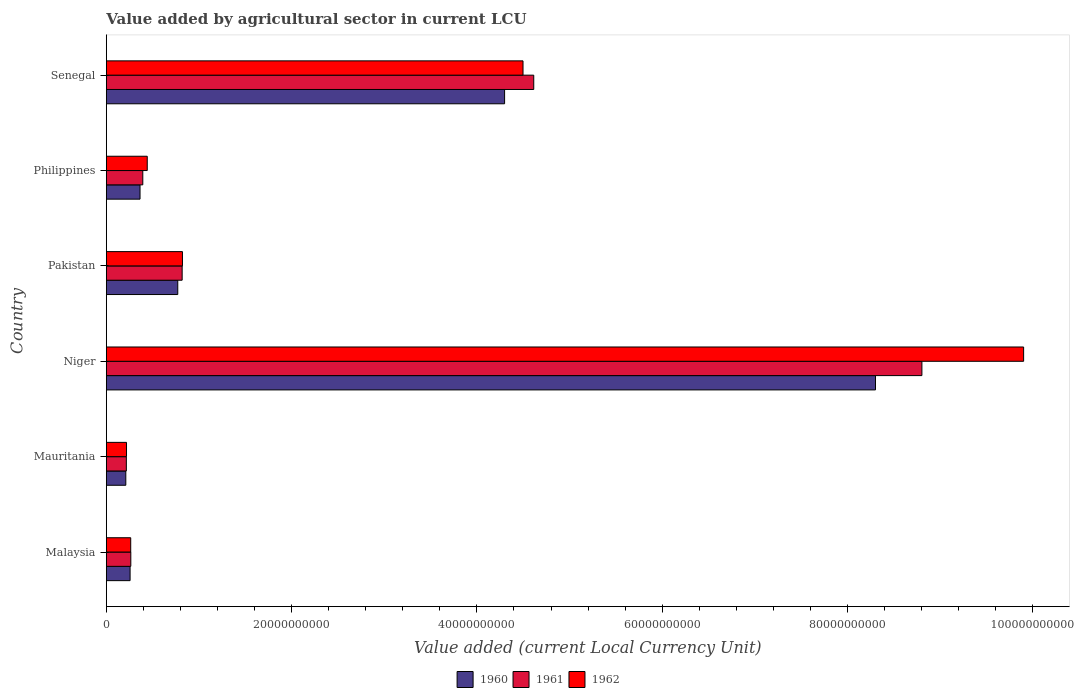How many different coloured bars are there?
Keep it short and to the point. 3. How many groups of bars are there?
Your response must be concise. 6. Are the number of bars per tick equal to the number of legend labels?
Provide a succinct answer. Yes. Are the number of bars on each tick of the Y-axis equal?
Your response must be concise. Yes. What is the label of the 6th group of bars from the top?
Give a very brief answer. Malaysia. What is the value added by agricultural sector in 1961 in Niger?
Offer a very short reply. 8.80e+1. Across all countries, what is the maximum value added by agricultural sector in 1960?
Your answer should be compact. 8.30e+1. Across all countries, what is the minimum value added by agricultural sector in 1960?
Keep it short and to the point. 2.10e+09. In which country was the value added by agricultural sector in 1961 maximum?
Your response must be concise. Niger. In which country was the value added by agricultural sector in 1962 minimum?
Offer a terse response. Mauritania. What is the total value added by agricultural sector in 1961 in the graph?
Make the answer very short. 1.51e+11. What is the difference between the value added by agricultural sector in 1962 in Malaysia and that in Pakistan?
Keep it short and to the point. -5.58e+09. What is the difference between the value added by agricultural sector in 1960 in Philippines and the value added by agricultural sector in 1961 in Niger?
Provide a short and direct response. -8.44e+1. What is the average value added by agricultural sector in 1962 per country?
Offer a very short reply. 2.69e+1. What is the difference between the value added by agricultural sector in 1960 and value added by agricultural sector in 1962 in Pakistan?
Offer a terse response. -5.05e+08. What is the ratio of the value added by agricultural sector in 1960 in Mauritania to that in Pakistan?
Keep it short and to the point. 0.27. Is the value added by agricultural sector in 1962 in Malaysia less than that in Pakistan?
Your response must be concise. Yes. What is the difference between the highest and the second highest value added by agricultural sector in 1960?
Offer a terse response. 4.00e+1. What is the difference between the highest and the lowest value added by agricultural sector in 1962?
Your response must be concise. 9.68e+1. Is the sum of the value added by agricultural sector in 1962 in Pakistan and Philippines greater than the maximum value added by agricultural sector in 1960 across all countries?
Ensure brevity in your answer.  No. What does the 3rd bar from the top in Mauritania represents?
Keep it short and to the point. 1960. What does the 1st bar from the bottom in Malaysia represents?
Offer a terse response. 1960. Is it the case that in every country, the sum of the value added by agricultural sector in 1961 and value added by agricultural sector in 1960 is greater than the value added by agricultural sector in 1962?
Your answer should be very brief. Yes. Are all the bars in the graph horizontal?
Offer a very short reply. Yes. What is the difference between two consecutive major ticks on the X-axis?
Your answer should be very brief. 2.00e+1. Does the graph contain any zero values?
Give a very brief answer. No. Where does the legend appear in the graph?
Keep it short and to the point. Bottom center. What is the title of the graph?
Make the answer very short. Value added by agricultural sector in current LCU. What is the label or title of the X-axis?
Provide a succinct answer. Value added (current Local Currency Unit). What is the Value added (current Local Currency Unit) of 1960 in Malaysia?
Keep it short and to the point. 2.56e+09. What is the Value added (current Local Currency Unit) of 1961 in Malaysia?
Make the answer very short. 2.64e+09. What is the Value added (current Local Currency Unit) in 1962 in Malaysia?
Your answer should be compact. 2.63e+09. What is the Value added (current Local Currency Unit) of 1960 in Mauritania?
Offer a very short reply. 2.10e+09. What is the Value added (current Local Currency Unit) in 1961 in Mauritania?
Keep it short and to the point. 2.16e+09. What is the Value added (current Local Currency Unit) of 1962 in Mauritania?
Provide a short and direct response. 2.18e+09. What is the Value added (current Local Currency Unit) in 1960 in Niger?
Your response must be concise. 8.30e+1. What is the Value added (current Local Currency Unit) of 1961 in Niger?
Give a very brief answer. 8.80e+1. What is the Value added (current Local Currency Unit) of 1962 in Niger?
Provide a short and direct response. 9.90e+1. What is the Value added (current Local Currency Unit) in 1960 in Pakistan?
Your answer should be very brief. 7.71e+09. What is the Value added (current Local Currency Unit) of 1961 in Pakistan?
Your response must be concise. 8.18e+09. What is the Value added (current Local Currency Unit) in 1962 in Pakistan?
Your response must be concise. 8.22e+09. What is the Value added (current Local Currency Unit) of 1960 in Philippines?
Make the answer very short. 3.64e+09. What is the Value added (current Local Currency Unit) in 1961 in Philippines?
Give a very brief answer. 3.94e+09. What is the Value added (current Local Currency Unit) of 1962 in Philippines?
Provide a short and direct response. 4.42e+09. What is the Value added (current Local Currency Unit) in 1960 in Senegal?
Offer a terse response. 4.30e+1. What is the Value added (current Local Currency Unit) of 1961 in Senegal?
Offer a terse response. 4.61e+1. What is the Value added (current Local Currency Unit) in 1962 in Senegal?
Provide a short and direct response. 4.50e+1. Across all countries, what is the maximum Value added (current Local Currency Unit) of 1960?
Give a very brief answer. 8.30e+1. Across all countries, what is the maximum Value added (current Local Currency Unit) of 1961?
Offer a terse response. 8.80e+1. Across all countries, what is the maximum Value added (current Local Currency Unit) in 1962?
Your answer should be compact. 9.90e+1. Across all countries, what is the minimum Value added (current Local Currency Unit) of 1960?
Offer a very short reply. 2.10e+09. Across all countries, what is the minimum Value added (current Local Currency Unit) of 1961?
Offer a terse response. 2.16e+09. Across all countries, what is the minimum Value added (current Local Currency Unit) of 1962?
Give a very brief answer. 2.18e+09. What is the total Value added (current Local Currency Unit) of 1960 in the graph?
Keep it short and to the point. 1.42e+11. What is the total Value added (current Local Currency Unit) in 1961 in the graph?
Your answer should be very brief. 1.51e+11. What is the total Value added (current Local Currency Unit) of 1962 in the graph?
Provide a succinct answer. 1.61e+11. What is the difference between the Value added (current Local Currency Unit) of 1960 in Malaysia and that in Mauritania?
Your answer should be very brief. 4.61e+08. What is the difference between the Value added (current Local Currency Unit) of 1961 in Malaysia and that in Mauritania?
Make the answer very short. 4.82e+08. What is the difference between the Value added (current Local Currency Unit) in 1962 in Malaysia and that in Mauritania?
Your response must be concise. 4.54e+08. What is the difference between the Value added (current Local Currency Unit) of 1960 in Malaysia and that in Niger?
Make the answer very short. -8.05e+1. What is the difference between the Value added (current Local Currency Unit) of 1961 in Malaysia and that in Niger?
Ensure brevity in your answer.  -8.54e+1. What is the difference between the Value added (current Local Currency Unit) of 1962 in Malaysia and that in Niger?
Your answer should be very brief. -9.64e+1. What is the difference between the Value added (current Local Currency Unit) of 1960 in Malaysia and that in Pakistan?
Offer a terse response. -5.15e+09. What is the difference between the Value added (current Local Currency Unit) of 1961 in Malaysia and that in Pakistan?
Offer a terse response. -5.54e+09. What is the difference between the Value added (current Local Currency Unit) of 1962 in Malaysia and that in Pakistan?
Provide a short and direct response. -5.58e+09. What is the difference between the Value added (current Local Currency Unit) of 1960 in Malaysia and that in Philippines?
Offer a very short reply. -1.07e+09. What is the difference between the Value added (current Local Currency Unit) of 1961 in Malaysia and that in Philippines?
Keep it short and to the point. -1.29e+09. What is the difference between the Value added (current Local Currency Unit) in 1962 in Malaysia and that in Philippines?
Keep it short and to the point. -1.78e+09. What is the difference between the Value added (current Local Currency Unit) in 1960 in Malaysia and that in Senegal?
Provide a short and direct response. -4.04e+1. What is the difference between the Value added (current Local Currency Unit) in 1961 in Malaysia and that in Senegal?
Your response must be concise. -4.35e+1. What is the difference between the Value added (current Local Currency Unit) in 1962 in Malaysia and that in Senegal?
Make the answer very short. -4.23e+1. What is the difference between the Value added (current Local Currency Unit) in 1960 in Mauritania and that in Niger?
Make the answer very short. -8.09e+1. What is the difference between the Value added (current Local Currency Unit) of 1961 in Mauritania and that in Niger?
Ensure brevity in your answer.  -8.59e+1. What is the difference between the Value added (current Local Currency Unit) in 1962 in Mauritania and that in Niger?
Keep it short and to the point. -9.68e+1. What is the difference between the Value added (current Local Currency Unit) of 1960 in Mauritania and that in Pakistan?
Provide a short and direct response. -5.61e+09. What is the difference between the Value added (current Local Currency Unit) of 1961 in Mauritania and that in Pakistan?
Offer a terse response. -6.02e+09. What is the difference between the Value added (current Local Currency Unit) of 1962 in Mauritania and that in Pakistan?
Your response must be concise. -6.04e+09. What is the difference between the Value added (current Local Currency Unit) in 1960 in Mauritania and that in Philippines?
Keep it short and to the point. -1.54e+09. What is the difference between the Value added (current Local Currency Unit) of 1961 in Mauritania and that in Philippines?
Give a very brief answer. -1.78e+09. What is the difference between the Value added (current Local Currency Unit) in 1962 in Mauritania and that in Philippines?
Offer a terse response. -2.24e+09. What is the difference between the Value added (current Local Currency Unit) of 1960 in Mauritania and that in Senegal?
Provide a succinct answer. -4.09e+1. What is the difference between the Value added (current Local Currency Unit) in 1961 in Mauritania and that in Senegal?
Your response must be concise. -4.40e+1. What is the difference between the Value added (current Local Currency Unit) in 1962 in Mauritania and that in Senegal?
Provide a succinct answer. -4.28e+1. What is the difference between the Value added (current Local Currency Unit) in 1960 in Niger and that in Pakistan?
Your answer should be compact. 7.53e+1. What is the difference between the Value added (current Local Currency Unit) in 1961 in Niger and that in Pakistan?
Offer a terse response. 7.98e+1. What is the difference between the Value added (current Local Currency Unit) in 1962 in Niger and that in Pakistan?
Your response must be concise. 9.08e+1. What is the difference between the Value added (current Local Currency Unit) in 1960 in Niger and that in Philippines?
Provide a short and direct response. 7.94e+1. What is the difference between the Value added (current Local Currency Unit) in 1961 in Niger and that in Philippines?
Your response must be concise. 8.41e+1. What is the difference between the Value added (current Local Currency Unit) of 1962 in Niger and that in Philippines?
Your answer should be very brief. 9.46e+1. What is the difference between the Value added (current Local Currency Unit) of 1960 in Niger and that in Senegal?
Make the answer very short. 4.00e+1. What is the difference between the Value added (current Local Currency Unit) in 1961 in Niger and that in Senegal?
Your answer should be compact. 4.19e+1. What is the difference between the Value added (current Local Currency Unit) in 1962 in Niger and that in Senegal?
Give a very brief answer. 5.40e+1. What is the difference between the Value added (current Local Currency Unit) of 1960 in Pakistan and that in Philippines?
Your answer should be very brief. 4.07e+09. What is the difference between the Value added (current Local Currency Unit) in 1961 in Pakistan and that in Philippines?
Keep it short and to the point. 4.25e+09. What is the difference between the Value added (current Local Currency Unit) in 1962 in Pakistan and that in Philippines?
Give a very brief answer. 3.80e+09. What is the difference between the Value added (current Local Currency Unit) in 1960 in Pakistan and that in Senegal?
Your response must be concise. -3.53e+1. What is the difference between the Value added (current Local Currency Unit) of 1961 in Pakistan and that in Senegal?
Your answer should be compact. -3.80e+1. What is the difference between the Value added (current Local Currency Unit) in 1962 in Pakistan and that in Senegal?
Offer a terse response. -3.68e+1. What is the difference between the Value added (current Local Currency Unit) of 1960 in Philippines and that in Senegal?
Your answer should be very brief. -3.94e+1. What is the difference between the Value added (current Local Currency Unit) in 1961 in Philippines and that in Senegal?
Give a very brief answer. -4.22e+1. What is the difference between the Value added (current Local Currency Unit) of 1962 in Philippines and that in Senegal?
Provide a short and direct response. -4.06e+1. What is the difference between the Value added (current Local Currency Unit) in 1960 in Malaysia and the Value added (current Local Currency Unit) in 1961 in Mauritania?
Offer a very short reply. 4.04e+08. What is the difference between the Value added (current Local Currency Unit) in 1960 in Malaysia and the Value added (current Local Currency Unit) in 1962 in Mauritania?
Offer a terse response. 3.86e+08. What is the difference between the Value added (current Local Currency Unit) of 1961 in Malaysia and the Value added (current Local Currency Unit) of 1962 in Mauritania?
Offer a terse response. 4.63e+08. What is the difference between the Value added (current Local Currency Unit) of 1960 in Malaysia and the Value added (current Local Currency Unit) of 1961 in Niger?
Your answer should be very brief. -8.55e+1. What is the difference between the Value added (current Local Currency Unit) in 1960 in Malaysia and the Value added (current Local Currency Unit) in 1962 in Niger?
Keep it short and to the point. -9.64e+1. What is the difference between the Value added (current Local Currency Unit) in 1961 in Malaysia and the Value added (current Local Currency Unit) in 1962 in Niger?
Your answer should be compact. -9.64e+1. What is the difference between the Value added (current Local Currency Unit) of 1960 in Malaysia and the Value added (current Local Currency Unit) of 1961 in Pakistan?
Offer a terse response. -5.62e+09. What is the difference between the Value added (current Local Currency Unit) in 1960 in Malaysia and the Value added (current Local Currency Unit) in 1962 in Pakistan?
Provide a succinct answer. -5.65e+09. What is the difference between the Value added (current Local Currency Unit) of 1961 in Malaysia and the Value added (current Local Currency Unit) of 1962 in Pakistan?
Your answer should be compact. -5.57e+09. What is the difference between the Value added (current Local Currency Unit) in 1960 in Malaysia and the Value added (current Local Currency Unit) in 1961 in Philippines?
Your response must be concise. -1.37e+09. What is the difference between the Value added (current Local Currency Unit) of 1960 in Malaysia and the Value added (current Local Currency Unit) of 1962 in Philippines?
Give a very brief answer. -1.85e+09. What is the difference between the Value added (current Local Currency Unit) in 1961 in Malaysia and the Value added (current Local Currency Unit) in 1962 in Philippines?
Give a very brief answer. -1.77e+09. What is the difference between the Value added (current Local Currency Unit) in 1960 in Malaysia and the Value added (current Local Currency Unit) in 1961 in Senegal?
Provide a succinct answer. -4.36e+1. What is the difference between the Value added (current Local Currency Unit) in 1960 in Malaysia and the Value added (current Local Currency Unit) in 1962 in Senegal?
Your answer should be very brief. -4.24e+1. What is the difference between the Value added (current Local Currency Unit) of 1961 in Malaysia and the Value added (current Local Currency Unit) of 1962 in Senegal?
Ensure brevity in your answer.  -4.23e+1. What is the difference between the Value added (current Local Currency Unit) in 1960 in Mauritania and the Value added (current Local Currency Unit) in 1961 in Niger?
Your answer should be compact. -8.59e+1. What is the difference between the Value added (current Local Currency Unit) in 1960 in Mauritania and the Value added (current Local Currency Unit) in 1962 in Niger?
Offer a terse response. -9.69e+1. What is the difference between the Value added (current Local Currency Unit) in 1961 in Mauritania and the Value added (current Local Currency Unit) in 1962 in Niger?
Offer a very short reply. -9.69e+1. What is the difference between the Value added (current Local Currency Unit) in 1960 in Mauritania and the Value added (current Local Currency Unit) in 1961 in Pakistan?
Keep it short and to the point. -6.08e+09. What is the difference between the Value added (current Local Currency Unit) of 1960 in Mauritania and the Value added (current Local Currency Unit) of 1962 in Pakistan?
Keep it short and to the point. -6.11e+09. What is the difference between the Value added (current Local Currency Unit) in 1961 in Mauritania and the Value added (current Local Currency Unit) in 1962 in Pakistan?
Keep it short and to the point. -6.06e+09. What is the difference between the Value added (current Local Currency Unit) in 1960 in Mauritania and the Value added (current Local Currency Unit) in 1961 in Philippines?
Your response must be concise. -1.83e+09. What is the difference between the Value added (current Local Currency Unit) of 1960 in Mauritania and the Value added (current Local Currency Unit) of 1962 in Philippines?
Your response must be concise. -2.31e+09. What is the difference between the Value added (current Local Currency Unit) in 1961 in Mauritania and the Value added (current Local Currency Unit) in 1962 in Philippines?
Make the answer very short. -2.26e+09. What is the difference between the Value added (current Local Currency Unit) in 1960 in Mauritania and the Value added (current Local Currency Unit) in 1961 in Senegal?
Your answer should be compact. -4.40e+1. What is the difference between the Value added (current Local Currency Unit) of 1960 in Mauritania and the Value added (current Local Currency Unit) of 1962 in Senegal?
Give a very brief answer. -4.29e+1. What is the difference between the Value added (current Local Currency Unit) in 1961 in Mauritania and the Value added (current Local Currency Unit) in 1962 in Senegal?
Provide a short and direct response. -4.28e+1. What is the difference between the Value added (current Local Currency Unit) in 1960 in Niger and the Value added (current Local Currency Unit) in 1961 in Pakistan?
Give a very brief answer. 7.48e+1. What is the difference between the Value added (current Local Currency Unit) in 1960 in Niger and the Value added (current Local Currency Unit) in 1962 in Pakistan?
Make the answer very short. 7.48e+1. What is the difference between the Value added (current Local Currency Unit) of 1961 in Niger and the Value added (current Local Currency Unit) of 1962 in Pakistan?
Offer a terse response. 7.98e+1. What is the difference between the Value added (current Local Currency Unit) of 1960 in Niger and the Value added (current Local Currency Unit) of 1961 in Philippines?
Your response must be concise. 7.91e+1. What is the difference between the Value added (current Local Currency Unit) in 1960 in Niger and the Value added (current Local Currency Unit) in 1962 in Philippines?
Provide a short and direct response. 7.86e+1. What is the difference between the Value added (current Local Currency Unit) of 1961 in Niger and the Value added (current Local Currency Unit) of 1962 in Philippines?
Offer a terse response. 8.36e+1. What is the difference between the Value added (current Local Currency Unit) of 1960 in Niger and the Value added (current Local Currency Unit) of 1961 in Senegal?
Ensure brevity in your answer.  3.69e+1. What is the difference between the Value added (current Local Currency Unit) of 1960 in Niger and the Value added (current Local Currency Unit) of 1962 in Senegal?
Your answer should be compact. 3.80e+1. What is the difference between the Value added (current Local Currency Unit) in 1961 in Niger and the Value added (current Local Currency Unit) in 1962 in Senegal?
Make the answer very short. 4.31e+1. What is the difference between the Value added (current Local Currency Unit) in 1960 in Pakistan and the Value added (current Local Currency Unit) in 1961 in Philippines?
Your response must be concise. 3.78e+09. What is the difference between the Value added (current Local Currency Unit) of 1960 in Pakistan and the Value added (current Local Currency Unit) of 1962 in Philippines?
Your response must be concise. 3.29e+09. What is the difference between the Value added (current Local Currency Unit) of 1961 in Pakistan and the Value added (current Local Currency Unit) of 1962 in Philippines?
Keep it short and to the point. 3.77e+09. What is the difference between the Value added (current Local Currency Unit) of 1960 in Pakistan and the Value added (current Local Currency Unit) of 1961 in Senegal?
Your answer should be compact. -3.84e+1. What is the difference between the Value added (current Local Currency Unit) in 1960 in Pakistan and the Value added (current Local Currency Unit) in 1962 in Senegal?
Your answer should be compact. -3.73e+1. What is the difference between the Value added (current Local Currency Unit) in 1961 in Pakistan and the Value added (current Local Currency Unit) in 1962 in Senegal?
Offer a terse response. -3.68e+1. What is the difference between the Value added (current Local Currency Unit) in 1960 in Philippines and the Value added (current Local Currency Unit) in 1961 in Senegal?
Your answer should be compact. -4.25e+1. What is the difference between the Value added (current Local Currency Unit) of 1960 in Philippines and the Value added (current Local Currency Unit) of 1962 in Senegal?
Offer a very short reply. -4.13e+1. What is the difference between the Value added (current Local Currency Unit) of 1961 in Philippines and the Value added (current Local Currency Unit) of 1962 in Senegal?
Provide a succinct answer. -4.10e+1. What is the average Value added (current Local Currency Unit) of 1960 per country?
Offer a very short reply. 2.37e+1. What is the average Value added (current Local Currency Unit) of 1961 per country?
Provide a short and direct response. 2.52e+1. What is the average Value added (current Local Currency Unit) in 1962 per country?
Keep it short and to the point. 2.69e+1. What is the difference between the Value added (current Local Currency Unit) in 1960 and Value added (current Local Currency Unit) in 1961 in Malaysia?
Your answer should be very brief. -7.78e+07. What is the difference between the Value added (current Local Currency Unit) of 1960 and Value added (current Local Currency Unit) of 1962 in Malaysia?
Provide a short and direct response. -6.83e+07. What is the difference between the Value added (current Local Currency Unit) of 1961 and Value added (current Local Currency Unit) of 1962 in Malaysia?
Make the answer very short. 9.46e+06. What is the difference between the Value added (current Local Currency Unit) of 1960 and Value added (current Local Currency Unit) of 1961 in Mauritania?
Give a very brief answer. -5.68e+07. What is the difference between the Value added (current Local Currency Unit) in 1960 and Value added (current Local Currency Unit) in 1962 in Mauritania?
Your response must be concise. -7.58e+07. What is the difference between the Value added (current Local Currency Unit) of 1961 and Value added (current Local Currency Unit) of 1962 in Mauritania?
Provide a succinct answer. -1.89e+07. What is the difference between the Value added (current Local Currency Unit) of 1960 and Value added (current Local Currency Unit) of 1961 in Niger?
Make the answer very short. -5.01e+09. What is the difference between the Value added (current Local Currency Unit) in 1960 and Value added (current Local Currency Unit) in 1962 in Niger?
Keep it short and to the point. -1.60e+1. What is the difference between the Value added (current Local Currency Unit) of 1961 and Value added (current Local Currency Unit) of 1962 in Niger?
Offer a terse response. -1.10e+1. What is the difference between the Value added (current Local Currency Unit) in 1960 and Value added (current Local Currency Unit) in 1961 in Pakistan?
Provide a short and direct response. -4.73e+08. What is the difference between the Value added (current Local Currency Unit) in 1960 and Value added (current Local Currency Unit) in 1962 in Pakistan?
Make the answer very short. -5.05e+08. What is the difference between the Value added (current Local Currency Unit) of 1961 and Value added (current Local Currency Unit) of 1962 in Pakistan?
Give a very brief answer. -3.20e+07. What is the difference between the Value added (current Local Currency Unit) of 1960 and Value added (current Local Currency Unit) of 1961 in Philippines?
Offer a terse response. -2.97e+08. What is the difference between the Value added (current Local Currency Unit) of 1960 and Value added (current Local Currency Unit) of 1962 in Philippines?
Your answer should be compact. -7.78e+08. What is the difference between the Value added (current Local Currency Unit) in 1961 and Value added (current Local Currency Unit) in 1962 in Philippines?
Your response must be concise. -4.81e+08. What is the difference between the Value added (current Local Currency Unit) in 1960 and Value added (current Local Currency Unit) in 1961 in Senegal?
Provide a short and direct response. -3.15e+09. What is the difference between the Value added (current Local Currency Unit) in 1960 and Value added (current Local Currency Unit) in 1962 in Senegal?
Offer a very short reply. -1.99e+09. What is the difference between the Value added (current Local Currency Unit) of 1961 and Value added (current Local Currency Unit) of 1962 in Senegal?
Offer a terse response. 1.16e+09. What is the ratio of the Value added (current Local Currency Unit) in 1960 in Malaysia to that in Mauritania?
Give a very brief answer. 1.22. What is the ratio of the Value added (current Local Currency Unit) of 1961 in Malaysia to that in Mauritania?
Provide a succinct answer. 1.22. What is the ratio of the Value added (current Local Currency Unit) in 1962 in Malaysia to that in Mauritania?
Your response must be concise. 1.21. What is the ratio of the Value added (current Local Currency Unit) in 1960 in Malaysia to that in Niger?
Ensure brevity in your answer.  0.03. What is the ratio of the Value added (current Local Currency Unit) of 1962 in Malaysia to that in Niger?
Your answer should be compact. 0.03. What is the ratio of the Value added (current Local Currency Unit) in 1960 in Malaysia to that in Pakistan?
Provide a short and direct response. 0.33. What is the ratio of the Value added (current Local Currency Unit) of 1961 in Malaysia to that in Pakistan?
Provide a short and direct response. 0.32. What is the ratio of the Value added (current Local Currency Unit) in 1962 in Malaysia to that in Pakistan?
Your response must be concise. 0.32. What is the ratio of the Value added (current Local Currency Unit) of 1960 in Malaysia to that in Philippines?
Your answer should be compact. 0.7. What is the ratio of the Value added (current Local Currency Unit) of 1961 in Malaysia to that in Philippines?
Your answer should be compact. 0.67. What is the ratio of the Value added (current Local Currency Unit) of 1962 in Malaysia to that in Philippines?
Your answer should be compact. 0.6. What is the ratio of the Value added (current Local Currency Unit) in 1960 in Malaysia to that in Senegal?
Make the answer very short. 0.06. What is the ratio of the Value added (current Local Currency Unit) in 1961 in Malaysia to that in Senegal?
Ensure brevity in your answer.  0.06. What is the ratio of the Value added (current Local Currency Unit) in 1962 in Malaysia to that in Senegal?
Your response must be concise. 0.06. What is the ratio of the Value added (current Local Currency Unit) of 1960 in Mauritania to that in Niger?
Ensure brevity in your answer.  0.03. What is the ratio of the Value added (current Local Currency Unit) in 1961 in Mauritania to that in Niger?
Make the answer very short. 0.02. What is the ratio of the Value added (current Local Currency Unit) of 1962 in Mauritania to that in Niger?
Provide a short and direct response. 0.02. What is the ratio of the Value added (current Local Currency Unit) in 1960 in Mauritania to that in Pakistan?
Provide a succinct answer. 0.27. What is the ratio of the Value added (current Local Currency Unit) in 1961 in Mauritania to that in Pakistan?
Give a very brief answer. 0.26. What is the ratio of the Value added (current Local Currency Unit) in 1962 in Mauritania to that in Pakistan?
Provide a short and direct response. 0.27. What is the ratio of the Value added (current Local Currency Unit) of 1960 in Mauritania to that in Philippines?
Make the answer very short. 0.58. What is the ratio of the Value added (current Local Currency Unit) in 1961 in Mauritania to that in Philippines?
Ensure brevity in your answer.  0.55. What is the ratio of the Value added (current Local Currency Unit) of 1962 in Mauritania to that in Philippines?
Ensure brevity in your answer.  0.49. What is the ratio of the Value added (current Local Currency Unit) in 1960 in Mauritania to that in Senegal?
Ensure brevity in your answer.  0.05. What is the ratio of the Value added (current Local Currency Unit) of 1961 in Mauritania to that in Senegal?
Your answer should be very brief. 0.05. What is the ratio of the Value added (current Local Currency Unit) in 1962 in Mauritania to that in Senegal?
Provide a succinct answer. 0.05. What is the ratio of the Value added (current Local Currency Unit) in 1960 in Niger to that in Pakistan?
Provide a succinct answer. 10.77. What is the ratio of the Value added (current Local Currency Unit) in 1961 in Niger to that in Pakistan?
Your response must be concise. 10.76. What is the ratio of the Value added (current Local Currency Unit) of 1962 in Niger to that in Pakistan?
Make the answer very short. 12.05. What is the ratio of the Value added (current Local Currency Unit) of 1960 in Niger to that in Philippines?
Keep it short and to the point. 22.82. What is the ratio of the Value added (current Local Currency Unit) in 1961 in Niger to that in Philippines?
Ensure brevity in your answer.  22.37. What is the ratio of the Value added (current Local Currency Unit) in 1962 in Niger to that in Philippines?
Offer a very short reply. 22.42. What is the ratio of the Value added (current Local Currency Unit) of 1960 in Niger to that in Senegal?
Ensure brevity in your answer.  1.93. What is the ratio of the Value added (current Local Currency Unit) of 1961 in Niger to that in Senegal?
Provide a succinct answer. 1.91. What is the ratio of the Value added (current Local Currency Unit) of 1962 in Niger to that in Senegal?
Give a very brief answer. 2.2. What is the ratio of the Value added (current Local Currency Unit) of 1960 in Pakistan to that in Philippines?
Ensure brevity in your answer.  2.12. What is the ratio of the Value added (current Local Currency Unit) in 1961 in Pakistan to that in Philippines?
Offer a very short reply. 2.08. What is the ratio of the Value added (current Local Currency Unit) of 1962 in Pakistan to that in Philippines?
Provide a short and direct response. 1.86. What is the ratio of the Value added (current Local Currency Unit) of 1960 in Pakistan to that in Senegal?
Offer a very short reply. 0.18. What is the ratio of the Value added (current Local Currency Unit) in 1961 in Pakistan to that in Senegal?
Your answer should be very brief. 0.18. What is the ratio of the Value added (current Local Currency Unit) of 1962 in Pakistan to that in Senegal?
Your answer should be very brief. 0.18. What is the ratio of the Value added (current Local Currency Unit) in 1960 in Philippines to that in Senegal?
Keep it short and to the point. 0.08. What is the ratio of the Value added (current Local Currency Unit) of 1961 in Philippines to that in Senegal?
Keep it short and to the point. 0.09. What is the ratio of the Value added (current Local Currency Unit) in 1962 in Philippines to that in Senegal?
Offer a very short reply. 0.1. What is the difference between the highest and the second highest Value added (current Local Currency Unit) in 1960?
Offer a terse response. 4.00e+1. What is the difference between the highest and the second highest Value added (current Local Currency Unit) of 1961?
Provide a short and direct response. 4.19e+1. What is the difference between the highest and the second highest Value added (current Local Currency Unit) of 1962?
Ensure brevity in your answer.  5.40e+1. What is the difference between the highest and the lowest Value added (current Local Currency Unit) of 1960?
Keep it short and to the point. 8.09e+1. What is the difference between the highest and the lowest Value added (current Local Currency Unit) of 1961?
Offer a very short reply. 8.59e+1. What is the difference between the highest and the lowest Value added (current Local Currency Unit) of 1962?
Give a very brief answer. 9.68e+1. 